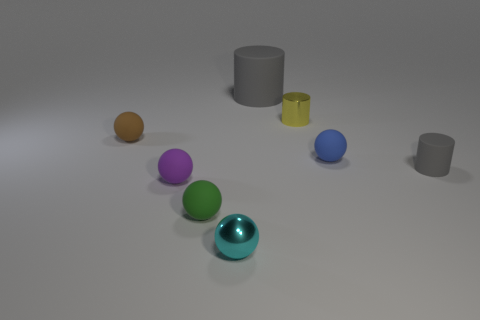What is the color of the other rubber thing that is the same shape as the large rubber thing?
Give a very brief answer. Gray. How many other objects are the same material as the tiny purple ball?
Keep it short and to the point. 5. How many red objects are small rubber balls or tiny metal objects?
Offer a terse response. 0. What size is the matte object that is the same color as the small rubber cylinder?
Offer a very short reply. Large. What number of things are on the left side of the cyan shiny ball?
Make the answer very short. 3. There is a gray matte cylinder to the right of the gray rubber thing that is behind the tiny matte ball to the left of the purple rubber ball; what is its size?
Keep it short and to the point. Small. Is there a tiny green sphere that is to the right of the small green ball that is behind the tiny shiny object that is in front of the brown matte ball?
Offer a terse response. No. Are there more tiny purple matte spheres than red blocks?
Your answer should be very brief. Yes. There is a sphere that is on the right side of the big gray object; what is its color?
Keep it short and to the point. Blue. Is the number of tiny purple matte things to the right of the small yellow object greater than the number of purple shiny objects?
Your answer should be very brief. No. 